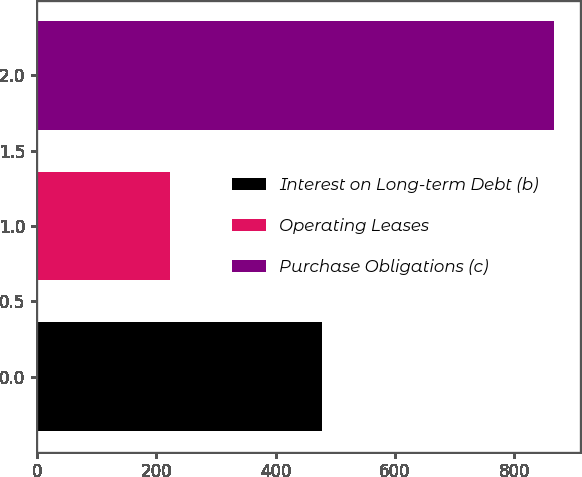Convert chart. <chart><loc_0><loc_0><loc_500><loc_500><bar_chart><fcel>Interest on Long-term Debt (b)<fcel>Operating Leases<fcel>Purchase Obligations (c)<nl><fcel>477<fcel>223<fcel>867<nl></chart> 